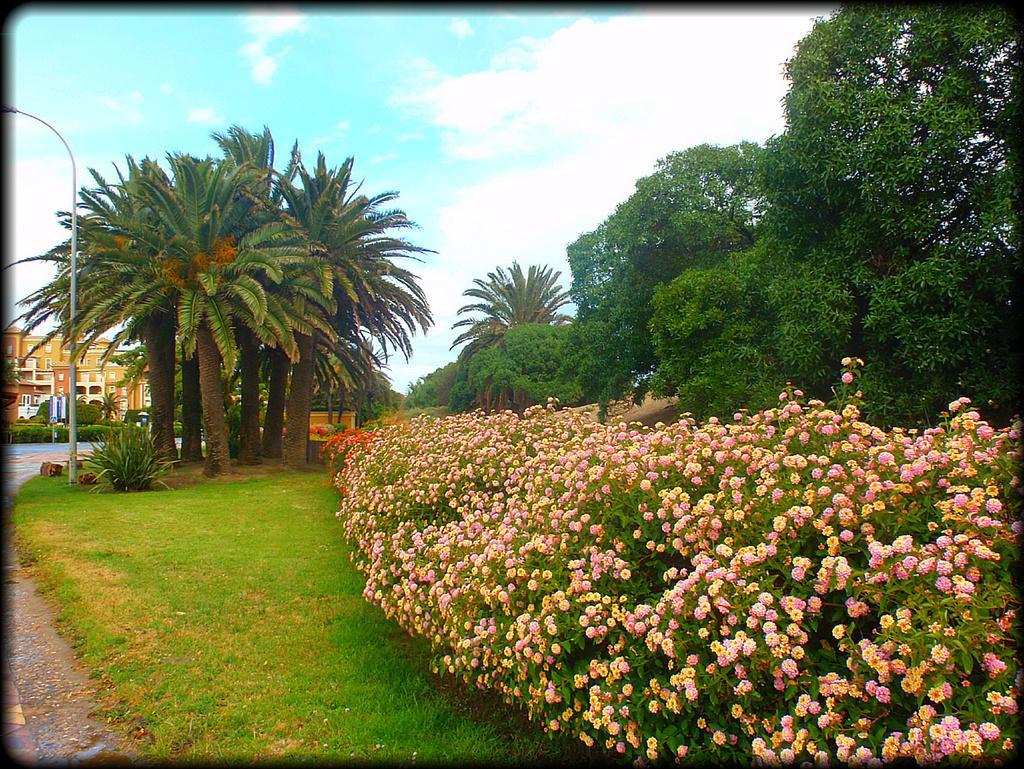How would you summarize this image in a sentence or two? In this image we can see some grass, flowers which are grown to the plants and in the background of the image there are some trees, street light poles, road and some buildings and top of the image there is clear sky. 